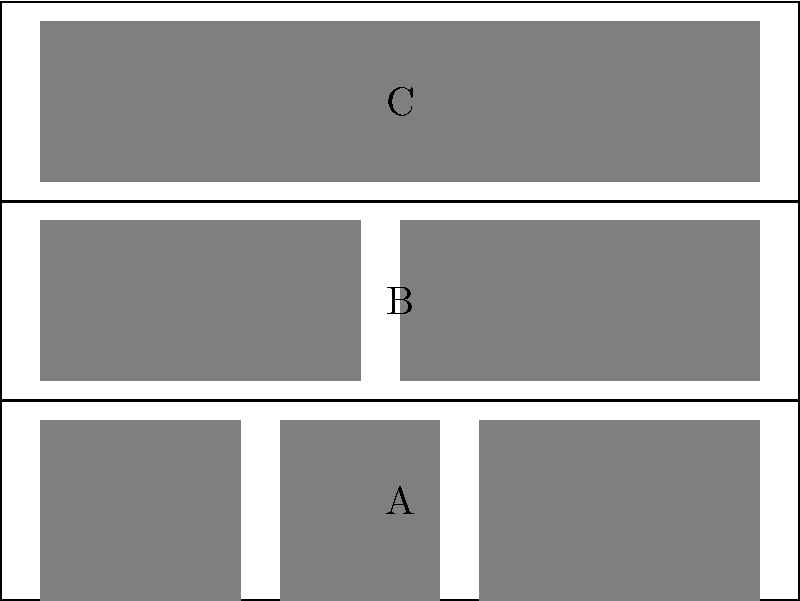In your writer's study, you have a bookshelf with three shelves (A, B, and C) as shown in the diagram. Each shelf can be rotated 180° independently. How many distinct arrangements of the bookshelf are possible, considering the symmetry group of these transformations? Let's approach this step-by-step:

1) First, we need to understand what transformations are possible:
   - Each shelf can be in its original position or rotated 180°.
   - These transformations can be applied independently to each shelf.

2) For each shelf, we have 2 possibilities:
   - Original position (let's call it 0)
   - Rotated 180° (let's call it 1)

3) We can represent each arrangement as a sequence of three binary digits, where each digit represents the state of a shelf (A, B, C in order).

4) The possible arrangements are:
   000, 001, 010, 011, 100, 101, 110, 111

5) To count the number of arrangements:
   - We have 2 choices for shelf A
   - For each choice of A, we have 2 choices for shelf B
   - For each choice of A and B, we have 2 choices for shelf C

6) Therefore, the total number of arrangements is:

   $$ 2 \times 2 \times 2 = 2^3 = 8 $$

This is equivalent to the order of the symmetry group for this bookshelf arrangement, which is isomorphic to the direct product of three $\mathbb{Z}_2$ groups: $\mathbb{Z}_2 \times \mathbb{Z}_2 \times \mathbb{Z}_2$.
Answer: 8 